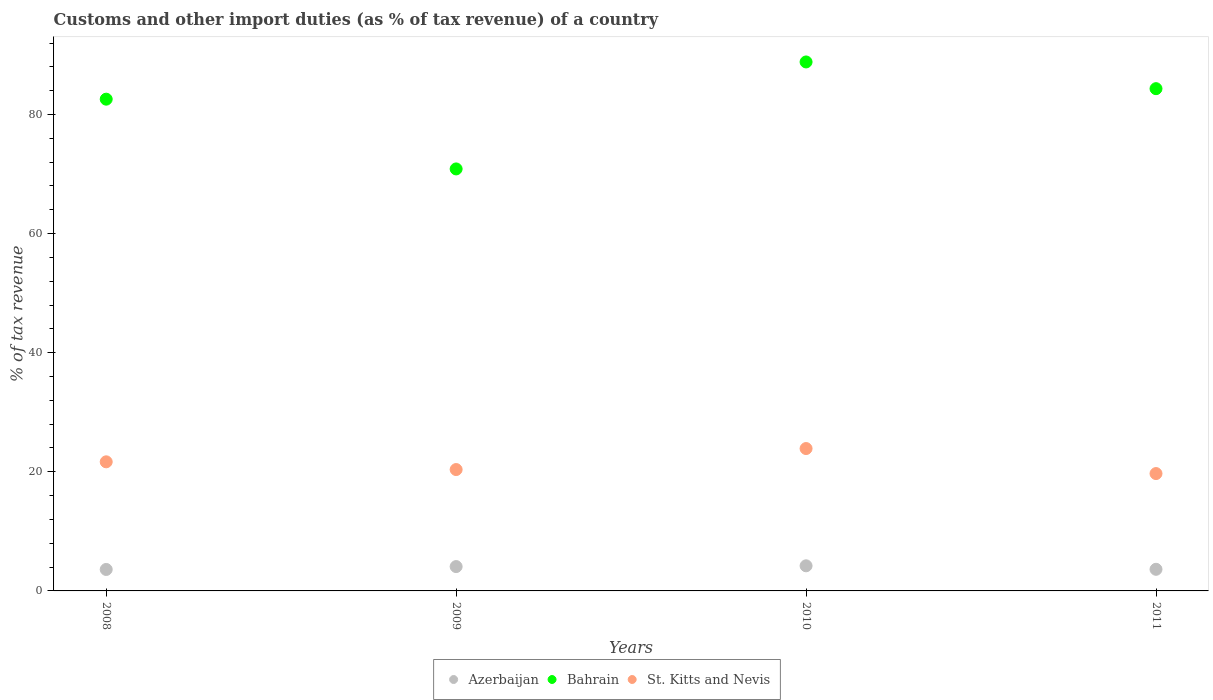How many different coloured dotlines are there?
Give a very brief answer. 3. Is the number of dotlines equal to the number of legend labels?
Ensure brevity in your answer.  Yes. What is the percentage of tax revenue from customs in Bahrain in 2008?
Keep it short and to the point. 82.57. Across all years, what is the maximum percentage of tax revenue from customs in St. Kitts and Nevis?
Make the answer very short. 23.91. Across all years, what is the minimum percentage of tax revenue from customs in Azerbaijan?
Keep it short and to the point. 3.6. In which year was the percentage of tax revenue from customs in St. Kitts and Nevis maximum?
Provide a succinct answer. 2010. In which year was the percentage of tax revenue from customs in St. Kitts and Nevis minimum?
Give a very brief answer. 2011. What is the total percentage of tax revenue from customs in Bahrain in the graph?
Ensure brevity in your answer.  326.59. What is the difference between the percentage of tax revenue from customs in Azerbaijan in 2009 and that in 2011?
Provide a succinct answer. 0.46. What is the difference between the percentage of tax revenue from customs in St. Kitts and Nevis in 2011 and the percentage of tax revenue from customs in Azerbaijan in 2009?
Make the answer very short. 15.62. What is the average percentage of tax revenue from customs in Azerbaijan per year?
Your answer should be very brief. 3.88. In the year 2010, what is the difference between the percentage of tax revenue from customs in Azerbaijan and percentage of tax revenue from customs in Bahrain?
Your response must be concise. -84.61. In how many years, is the percentage of tax revenue from customs in Azerbaijan greater than 16 %?
Provide a succinct answer. 0. What is the ratio of the percentage of tax revenue from customs in St. Kitts and Nevis in 2008 to that in 2010?
Keep it short and to the point. 0.91. What is the difference between the highest and the second highest percentage of tax revenue from customs in Azerbaijan?
Make the answer very short. 0.13. What is the difference between the highest and the lowest percentage of tax revenue from customs in Azerbaijan?
Make the answer very short. 0.61. In how many years, is the percentage of tax revenue from customs in Azerbaijan greater than the average percentage of tax revenue from customs in Azerbaijan taken over all years?
Provide a succinct answer. 2. Is it the case that in every year, the sum of the percentage of tax revenue from customs in Azerbaijan and percentage of tax revenue from customs in St. Kitts and Nevis  is greater than the percentage of tax revenue from customs in Bahrain?
Keep it short and to the point. No. Does the percentage of tax revenue from customs in Bahrain monotonically increase over the years?
Give a very brief answer. No. Is the percentage of tax revenue from customs in Bahrain strictly greater than the percentage of tax revenue from customs in Azerbaijan over the years?
Your answer should be compact. Yes. How many dotlines are there?
Your answer should be compact. 3. What is the difference between two consecutive major ticks on the Y-axis?
Your response must be concise. 20. Does the graph contain any zero values?
Offer a terse response. No. What is the title of the graph?
Make the answer very short. Customs and other import duties (as % of tax revenue) of a country. What is the label or title of the Y-axis?
Provide a short and direct response. % of tax revenue. What is the % of tax revenue in Azerbaijan in 2008?
Give a very brief answer. 3.6. What is the % of tax revenue of Bahrain in 2008?
Make the answer very short. 82.57. What is the % of tax revenue in St. Kitts and Nevis in 2008?
Make the answer very short. 21.68. What is the % of tax revenue in Azerbaijan in 2009?
Your answer should be compact. 4.09. What is the % of tax revenue in Bahrain in 2009?
Your answer should be compact. 70.86. What is the % of tax revenue in St. Kitts and Nevis in 2009?
Provide a short and direct response. 20.38. What is the % of tax revenue of Azerbaijan in 2010?
Give a very brief answer. 4.22. What is the % of tax revenue of Bahrain in 2010?
Ensure brevity in your answer.  88.82. What is the % of tax revenue of St. Kitts and Nevis in 2010?
Your answer should be compact. 23.91. What is the % of tax revenue of Azerbaijan in 2011?
Offer a very short reply. 3.63. What is the % of tax revenue of Bahrain in 2011?
Your answer should be very brief. 84.34. What is the % of tax revenue in St. Kitts and Nevis in 2011?
Make the answer very short. 19.71. Across all years, what is the maximum % of tax revenue of Azerbaijan?
Your response must be concise. 4.22. Across all years, what is the maximum % of tax revenue in Bahrain?
Your answer should be very brief. 88.82. Across all years, what is the maximum % of tax revenue in St. Kitts and Nevis?
Your answer should be very brief. 23.91. Across all years, what is the minimum % of tax revenue of Azerbaijan?
Give a very brief answer. 3.6. Across all years, what is the minimum % of tax revenue of Bahrain?
Your answer should be compact. 70.86. Across all years, what is the minimum % of tax revenue in St. Kitts and Nevis?
Your response must be concise. 19.71. What is the total % of tax revenue of Azerbaijan in the graph?
Your response must be concise. 15.54. What is the total % of tax revenue of Bahrain in the graph?
Make the answer very short. 326.59. What is the total % of tax revenue of St. Kitts and Nevis in the graph?
Offer a very short reply. 85.67. What is the difference between the % of tax revenue of Azerbaijan in 2008 and that in 2009?
Ensure brevity in your answer.  -0.48. What is the difference between the % of tax revenue in Bahrain in 2008 and that in 2009?
Offer a terse response. 11.71. What is the difference between the % of tax revenue of St. Kitts and Nevis in 2008 and that in 2009?
Provide a short and direct response. 1.3. What is the difference between the % of tax revenue in Azerbaijan in 2008 and that in 2010?
Ensure brevity in your answer.  -0.61. What is the difference between the % of tax revenue of Bahrain in 2008 and that in 2010?
Make the answer very short. -6.25. What is the difference between the % of tax revenue of St. Kitts and Nevis in 2008 and that in 2010?
Provide a succinct answer. -2.23. What is the difference between the % of tax revenue of Azerbaijan in 2008 and that in 2011?
Offer a terse response. -0.03. What is the difference between the % of tax revenue of Bahrain in 2008 and that in 2011?
Make the answer very short. -1.76. What is the difference between the % of tax revenue in St. Kitts and Nevis in 2008 and that in 2011?
Give a very brief answer. 1.97. What is the difference between the % of tax revenue in Azerbaijan in 2009 and that in 2010?
Offer a terse response. -0.13. What is the difference between the % of tax revenue in Bahrain in 2009 and that in 2010?
Provide a succinct answer. -17.96. What is the difference between the % of tax revenue of St. Kitts and Nevis in 2009 and that in 2010?
Your answer should be very brief. -3.53. What is the difference between the % of tax revenue of Azerbaijan in 2009 and that in 2011?
Give a very brief answer. 0.46. What is the difference between the % of tax revenue of Bahrain in 2009 and that in 2011?
Give a very brief answer. -13.48. What is the difference between the % of tax revenue in St. Kitts and Nevis in 2009 and that in 2011?
Keep it short and to the point. 0.67. What is the difference between the % of tax revenue in Azerbaijan in 2010 and that in 2011?
Make the answer very short. 0.59. What is the difference between the % of tax revenue of Bahrain in 2010 and that in 2011?
Offer a terse response. 4.49. What is the difference between the % of tax revenue of St. Kitts and Nevis in 2010 and that in 2011?
Give a very brief answer. 4.2. What is the difference between the % of tax revenue of Azerbaijan in 2008 and the % of tax revenue of Bahrain in 2009?
Make the answer very short. -67.26. What is the difference between the % of tax revenue of Azerbaijan in 2008 and the % of tax revenue of St. Kitts and Nevis in 2009?
Keep it short and to the point. -16.78. What is the difference between the % of tax revenue in Bahrain in 2008 and the % of tax revenue in St. Kitts and Nevis in 2009?
Provide a succinct answer. 62.19. What is the difference between the % of tax revenue of Azerbaijan in 2008 and the % of tax revenue of Bahrain in 2010?
Provide a succinct answer. -85.22. What is the difference between the % of tax revenue in Azerbaijan in 2008 and the % of tax revenue in St. Kitts and Nevis in 2010?
Keep it short and to the point. -20.3. What is the difference between the % of tax revenue in Bahrain in 2008 and the % of tax revenue in St. Kitts and Nevis in 2010?
Your answer should be compact. 58.67. What is the difference between the % of tax revenue in Azerbaijan in 2008 and the % of tax revenue in Bahrain in 2011?
Offer a very short reply. -80.73. What is the difference between the % of tax revenue of Azerbaijan in 2008 and the % of tax revenue of St. Kitts and Nevis in 2011?
Give a very brief answer. -16.1. What is the difference between the % of tax revenue of Bahrain in 2008 and the % of tax revenue of St. Kitts and Nevis in 2011?
Your response must be concise. 62.87. What is the difference between the % of tax revenue in Azerbaijan in 2009 and the % of tax revenue in Bahrain in 2010?
Your answer should be compact. -84.74. What is the difference between the % of tax revenue in Azerbaijan in 2009 and the % of tax revenue in St. Kitts and Nevis in 2010?
Provide a succinct answer. -19.82. What is the difference between the % of tax revenue of Bahrain in 2009 and the % of tax revenue of St. Kitts and Nevis in 2010?
Keep it short and to the point. 46.95. What is the difference between the % of tax revenue of Azerbaijan in 2009 and the % of tax revenue of Bahrain in 2011?
Provide a succinct answer. -80.25. What is the difference between the % of tax revenue of Azerbaijan in 2009 and the % of tax revenue of St. Kitts and Nevis in 2011?
Make the answer very short. -15.62. What is the difference between the % of tax revenue of Bahrain in 2009 and the % of tax revenue of St. Kitts and Nevis in 2011?
Keep it short and to the point. 51.15. What is the difference between the % of tax revenue of Azerbaijan in 2010 and the % of tax revenue of Bahrain in 2011?
Your answer should be compact. -80.12. What is the difference between the % of tax revenue in Azerbaijan in 2010 and the % of tax revenue in St. Kitts and Nevis in 2011?
Offer a very short reply. -15.49. What is the difference between the % of tax revenue in Bahrain in 2010 and the % of tax revenue in St. Kitts and Nevis in 2011?
Keep it short and to the point. 69.12. What is the average % of tax revenue of Azerbaijan per year?
Keep it short and to the point. 3.88. What is the average % of tax revenue of Bahrain per year?
Provide a short and direct response. 81.65. What is the average % of tax revenue in St. Kitts and Nevis per year?
Keep it short and to the point. 21.42. In the year 2008, what is the difference between the % of tax revenue in Azerbaijan and % of tax revenue in Bahrain?
Ensure brevity in your answer.  -78.97. In the year 2008, what is the difference between the % of tax revenue in Azerbaijan and % of tax revenue in St. Kitts and Nevis?
Offer a terse response. -18.07. In the year 2008, what is the difference between the % of tax revenue of Bahrain and % of tax revenue of St. Kitts and Nevis?
Offer a very short reply. 60.89. In the year 2009, what is the difference between the % of tax revenue in Azerbaijan and % of tax revenue in Bahrain?
Keep it short and to the point. -66.77. In the year 2009, what is the difference between the % of tax revenue of Azerbaijan and % of tax revenue of St. Kitts and Nevis?
Provide a short and direct response. -16.29. In the year 2009, what is the difference between the % of tax revenue of Bahrain and % of tax revenue of St. Kitts and Nevis?
Provide a short and direct response. 50.48. In the year 2010, what is the difference between the % of tax revenue in Azerbaijan and % of tax revenue in Bahrain?
Ensure brevity in your answer.  -84.61. In the year 2010, what is the difference between the % of tax revenue in Azerbaijan and % of tax revenue in St. Kitts and Nevis?
Your response must be concise. -19.69. In the year 2010, what is the difference between the % of tax revenue in Bahrain and % of tax revenue in St. Kitts and Nevis?
Provide a succinct answer. 64.92. In the year 2011, what is the difference between the % of tax revenue of Azerbaijan and % of tax revenue of Bahrain?
Your answer should be very brief. -80.71. In the year 2011, what is the difference between the % of tax revenue in Azerbaijan and % of tax revenue in St. Kitts and Nevis?
Offer a terse response. -16.08. In the year 2011, what is the difference between the % of tax revenue in Bahrain and % of tax revenue in St. Kitts and Nevis?
Give a very brief answer. 64.63. What is the ratio of the % of tax revenue in Azerbaijan in 2008 to that in 2009?
Your answer should be compact. 0.88. What is the ratio of the % of tax revenue of Bahrain in 2008 to that in 2009?
Provide a succinct answer. 1.17. What is the ratio of the % of tax revenue of St. Kitts and Nevis in 2008 to that in 2009?
Your answer should be compact. 1.06. What is the ratio of the % of tax revenue in Azerbaijan in 2008 to that in 2010?
Make the answer very short. 0.85. What is the ratio of the % of tax revenue in Bahrain in 2008 to that in 2010?
Your answer should be compact. 0.93. What is the ratio of the % of tax revenue of St. Kitts and Nevis in 2008 to that in 2010?
Offer a terse response. 0.91. What is the ratio of the % of tax revenue in Azerbaijan in 2008 to that in 2011?
Keep it short and to the point. 0.99. What is the ratio of the % of tax revenue in Bahrain in 2008 to that in 2011?
Provide a short and direct response. 0.98. What is the ratio of the % of tax revenue of St. Kitts and Nevis in 2008 to that in 2011?
Provide a short and direct response. 1.1. What is the ratio of the % of tax revenue in Azerbaijan in 2009 to that in 2010?
Keep it short and to the point. 0.97. What is the ratio of the % of tax revenue of Bahrain in 2009 to that in 2010?
Give a very brief answer. 0.8. What is the ratio of the % of tax revenue in St. Kitts and Nevis in 2009 to that in 2010?
Keep it short and to the point. 0.85. What is the ratio of the % of tax revenue of Azerbaijan in 2009 to that in 2011?
Keep it short and to the point. 1.13. What is the ratio of the % of tax revenue in Bahrain in 2009 to that in 2011?
Your answer should be very brief. 0.84. What is the ratio of the % of tax revenue of St. Kitts and Nevis in 2009 to that in 2011?
Ensure brevity in your answer.  1.03. What is the ratio of the % of tax revenue in Azerbaijan in 2010 to that in 2011?
Your response must be concise. 1.16. What is the ratio of the % of tax revenue of Bahrain in 2010 to that in 2011?
Provide a succinct answer. 1.05. What is the ratio of the % of tax revenue of St. Kitts and Nevis in 2010 to that in 2011?
Provide a short and direct response. 1.21. What is the difference between the highest and the second highest % of tax revenue of Azerbaijan?
Provide a succinct answer. 0.13. What is the difference between the highest and the second highest % of tax revenue in Bahrain?
Provide a short and direct response. 4.49. What is the difference between the highest and the second highest % of tax revenue of St. Kitts and Nevis?
Provide a short and direct response. 2.23. What is the difference between the highest and the lowest % of tax revenue in Azerbaijan?
Offer a terse response. 0.61. What is the difference between the highest and the lowest % of tax revenue of Bahrain?
Your response must be concise. 17.96. What is the difference between the highest and the lowest % of tax revenue of St. Kitts and Nevis?
Ensure brevity in your answer.  4.2. 